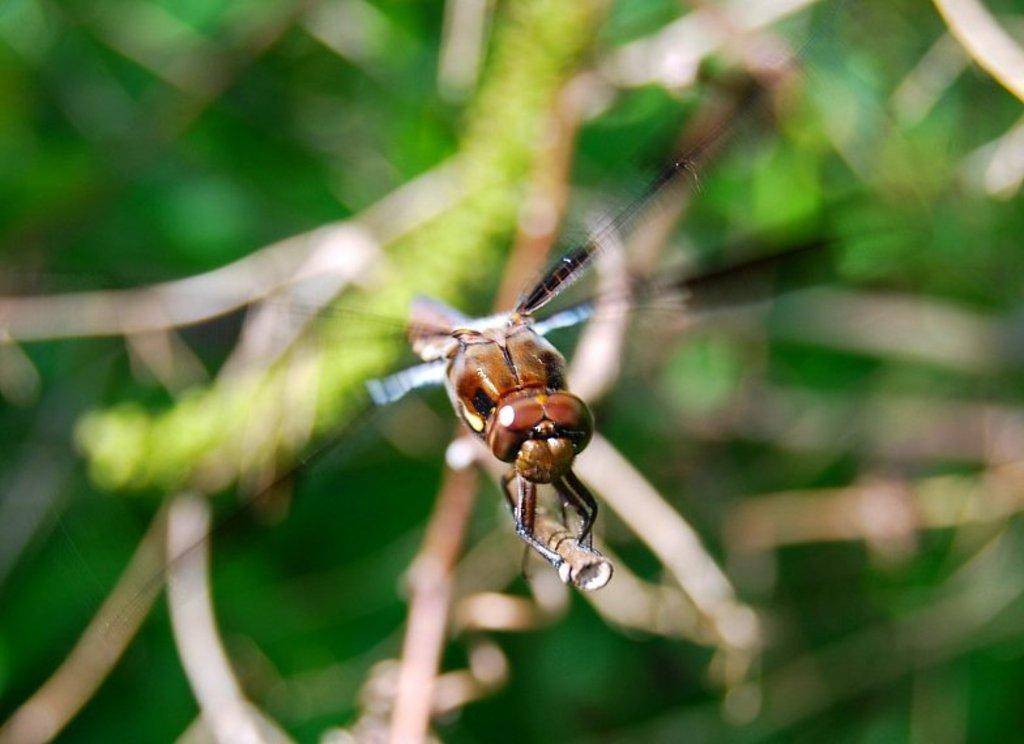What is present on the plant in the image? There is a fly on a plant in the image. Can you describe the background of the image? The background of the image is blurred. What type of furniture can be seen in the image? There is no furniture present in the image; it features a fly on a plant with a blurred background. What kind of music is playing in the background of the image? There is no music present in the image; it features a fly on a plant with a blurred background. 